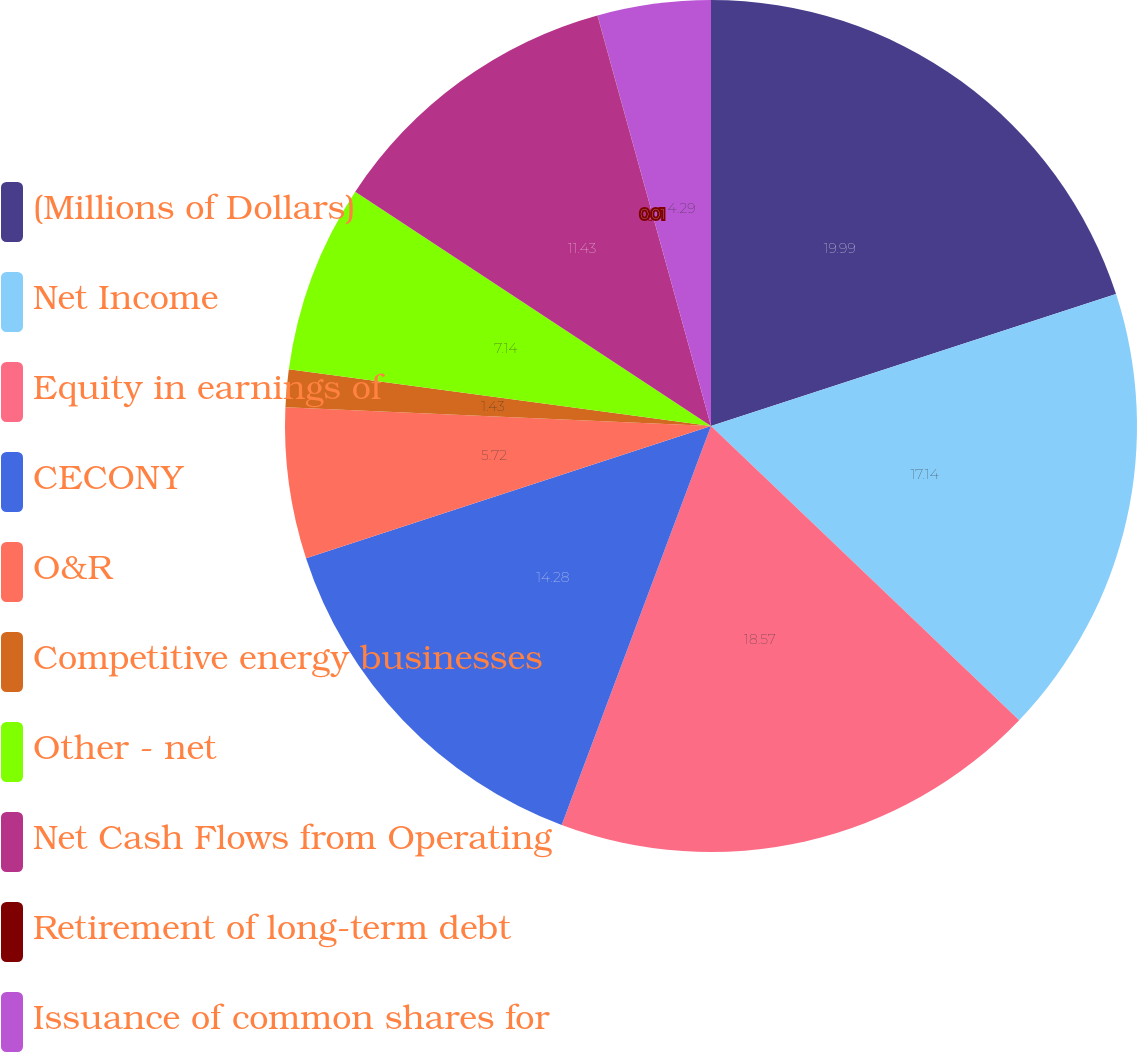Convert chart. <chart><loc_0><loc_0><loc_500><loc_500><pie_chart><fcel>(Millions of Dollars)<fcel>Net Income<fcel>Equity in earnings of<fcel>CECONY<fcel>O&R<fcel>Competitive energy businesses<fcel>Other - net<fcel>Net Cash Flows from Operating<fcel>Retirement of long-term debt<fcel>Issuance of common shares for<nl><fcel>19.99%<fcel>17.14%<fcel>18.57%<fcel>14.28%<fcel>5.72%<fcel>1.43%<fcel>7.14%<fcel>11.43%<fcel>0.01%<fcel>4.29%<nl></chart> 